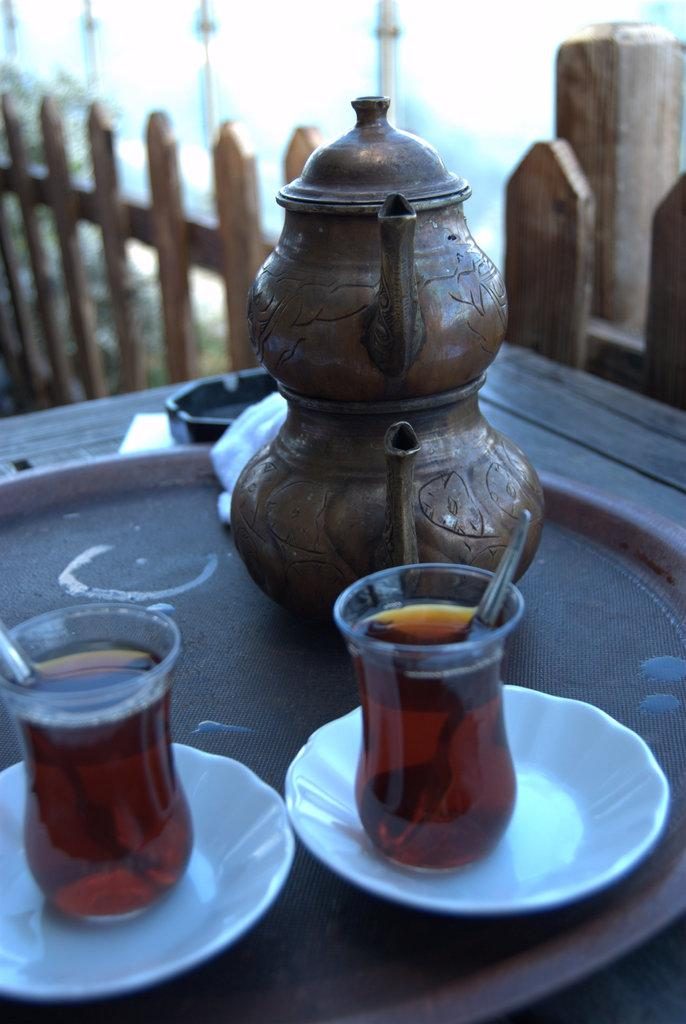What piece of furniture is present in the image? There is a table in the image. What objects are on the table? There are teapots and two glasses with a drink in them on the table. How are the glasses positioned on the table? The glasses are on saucers, which are on a plate. What type of horse can be seen attacking the teapots in the image? There is no horse or attack present in the image; it only features a table with teapots, glasses, saucers, and a plate. 